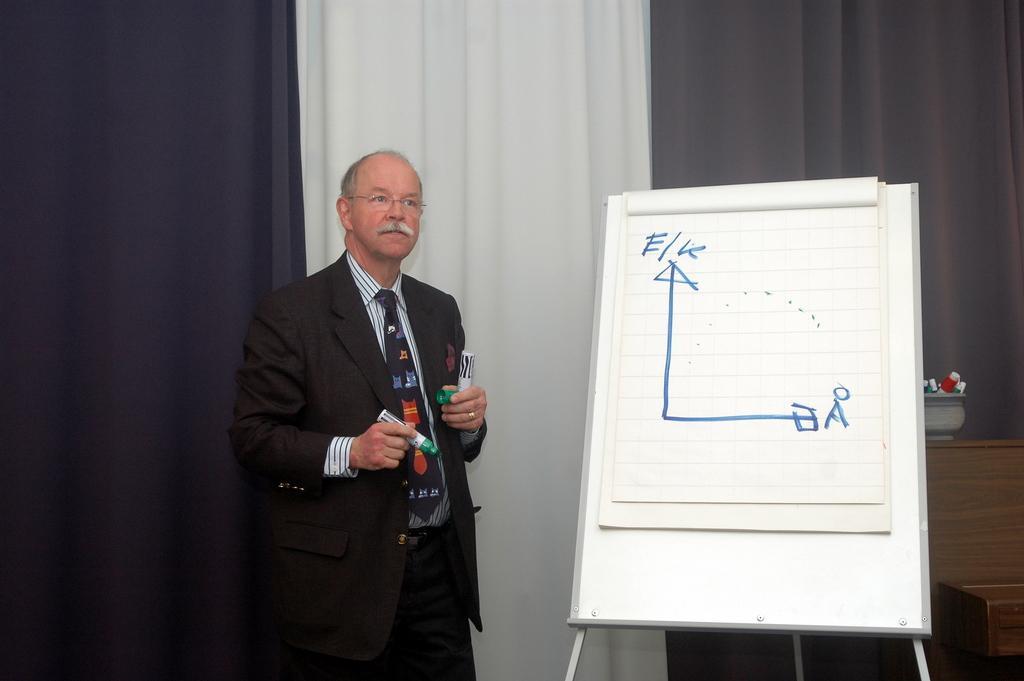Can you describe this image briefly? In this image, at the left side there is a man standing and he is holding a marker, at the right side there is a white color board, in the background there are some curtains. 